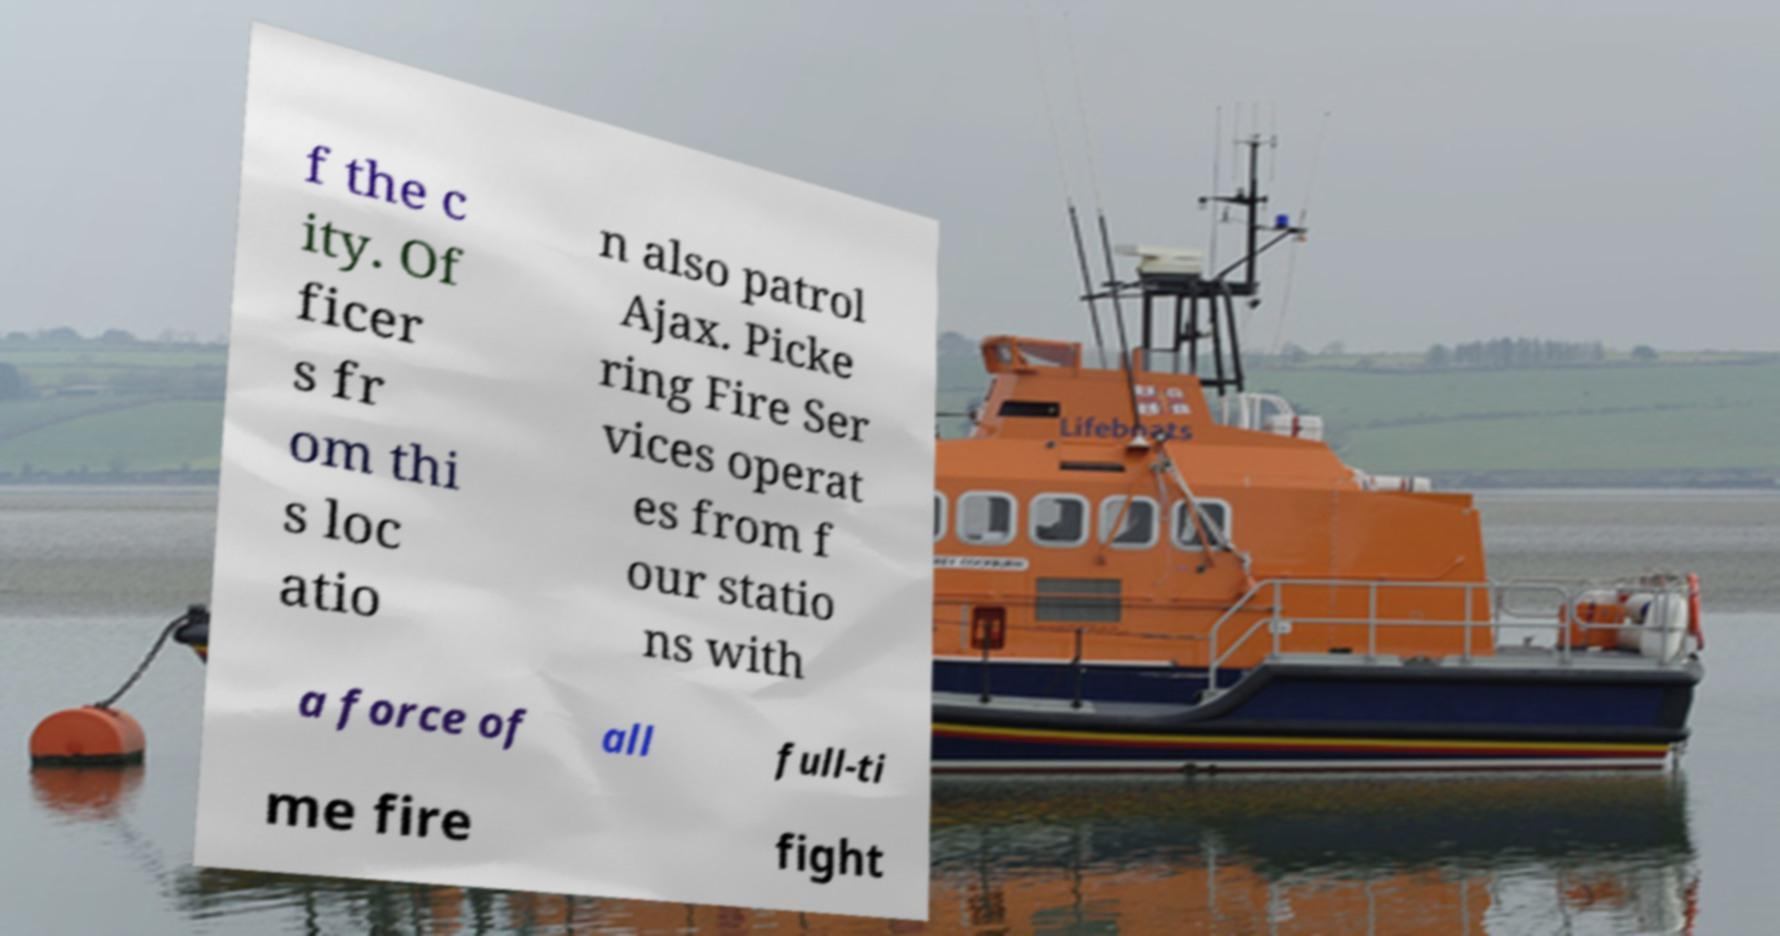Can you accurately transcribe the text from the provided image for me? f the c ity. Of ficer s fr om thi s loc atio n also patrol Ajax. Picke ring Fire Ser vices operat es from f our statio ns with a force of all full-ti me fire fight 